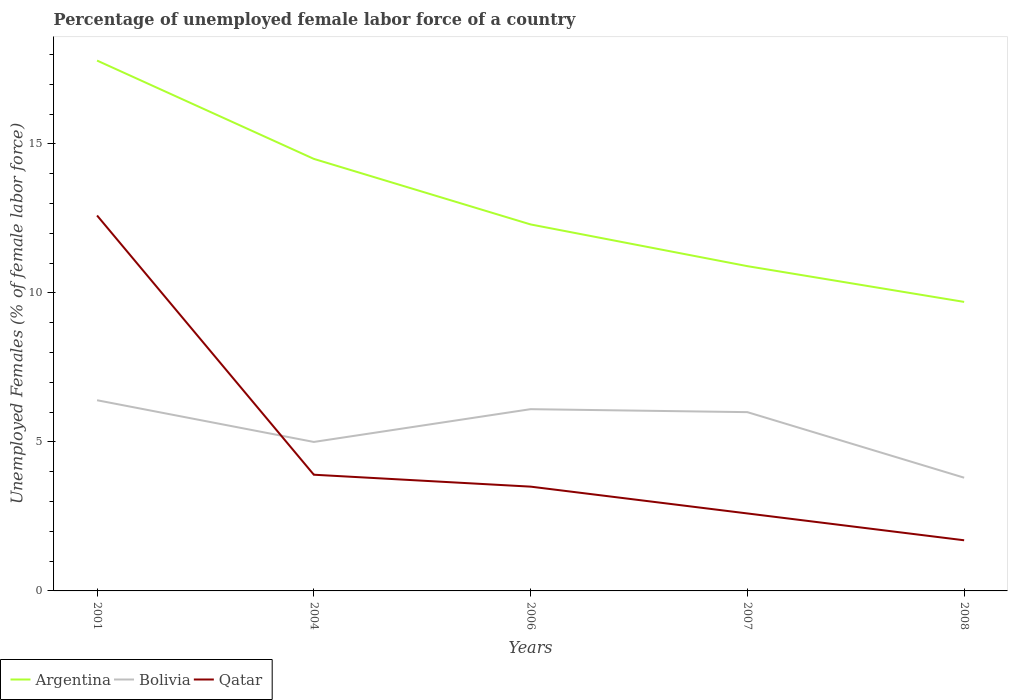How many different coloured lines are there?
Offer a very short reply. 3. Does the line corresponding to Qatar intersect with the line corresponding to Argentina?
Keep it short and to the point. No. Is the number of lines equal to the number of legend labels?
Offer a very short reply. Yes. Across all years, what is the maximum percentage of unemployed female labor force in Bolivia?
Provide a short and direct response. 3.8. In which year was the percentage of unemployed female labor force in Bolivia maximum?
Your response must be concise. 2008. What is the total percentage of unemployed female labor force in Argentina in the graph?
Make the answer very short. 2.2. What is the difference between the highest and the second highest percentage of unemployed female labor force in Qatar?
Keep it short and to the point. 10.9. What is the difference between the highest and the lowest percentage of unemployed female labor force in Argentina?
Ensure brevity in your answer.  2. Is the percentage of unemployed female labor force in Argentina strictly greater than the percentage of unemployed female labor force in Bolivia over the years?
Your answer should be compact. No. How many lines are there?
Offer a very short reply. 3. How many years are there in the graph?
Give a very brief answer. 5. Are the values on the major ticks of Y-axis written in scientific E-notation?
Offer a very short reply. No. Does the graph contain any zero values?
Offer a very short reply. No. How are the legend labels stacked?
Provide a succinct answer. Horizontal. What is the title of the graph?
Your answer should be compact. Percentage of unemployed female labor force of a country. Does "Syrian Arab Republic" appear as one of the legend labels in the graph?
Provide a succinct answer. No. What is the label or title of the Y-axis?
Keep it short and to the point. Unemployed Females (% of female labor force). What is the Unemployed Females (% of female labor force) of Argentina in 2001?
Make the answer very short. 17.8. What is the Unemployed Females (% of female labor force) in Bolivia in 2001?
Give a very brief answer. 6.4. What is the Unemployed Females (% of female labor force) of Qatar in 2001?
Make the answer very short. 12.6. What is the Unemployed Females (% of female labor force) in Bolivia in 2004?
Your response must be concise. 5. What is the Unemployed Females (% of female labor force) in Qatar in 2004?
Your response must be concise. 3.9. What is the Unemployed Females (% of female labor force) in Argentina in 2006?
Your answer should be very brief. 12.3. What is the Unemployed Females (% of female labor force) in Bolivia in 2006?
Your answer should be compact. 6.1. What is the Unemployed Females (% of female labor force) of Qatar in 2006?
Offer a terse response. 3.5. What is the Unemployed Females (% of female labor force) of Argentina in 2007?
Your response must be concise. 10.9. What is the Unemployed Females (% of female labor force) of Qatar in 2007?
Offer a very short reply. 2.6. What is the Unemployed Females (% of female labor force) of Argentina in 2008?
Make the answer very short. 9.7. What is the Unemployed Females (% of female labor force) in Bolivia in 2008?
Your answer should be compact. 3.8. What is the Unemployed Females (% of female labor force) of Qatar in 2008?
Your answer should be very brief. 1.7. Across all years, what is the maximum Unemployed Females (% of female labor force) in Argentina?
Provide a short and direct response. 17.8. Across all years, what is the maximum Unemployed Females (% of female labor force) of Bolivia?
Provide a succinct answer. 6.4. Across all years, what is the maximum Unemployed Females (% of female labor force) of Qatar?
Your answer should be very brief. 12.6. Across all years, what is the minimum Unemployed Females (% of female labor force) in Argentina?
Your answer should be very brief. 9.7. Across all years, what is the minimum Unemployed Females (% of female labor force) of Bolivia?
Ensure brevity in your answer.  3.8. Across all years, what is the minimum Unemployed Females (% of female labor force) of Qatar?
Give a very brief answer. 1.7. What is the total Unemployed Females (% of female labor force) in Argentina in the graph?
Provide a succinct answer. 65.2. What is the total Unemployed Females (% of female labor force) in Bolivia in the graph?
Your response must be concise. 27.3. What is the total Unemployed Females (% of female labor force) in Qatar in the graph?
Give a very brief answer. 24.3. What is the difference between the Unemployed Females (% of female labor force) in Argentina in 2001 and that in 2004?
Offer a very short reply. 3.3. What is the difference between the Unemployed Females (% of female labor force) of Bolivia in 2001 and that in 2004?
Offer a very short reply. 1.4. What is the difference between the Unemployed Females (% of female labor force) of Qatar in 2001 and that in 2004?
Your answer should be very brief. 8.7. What is the difference between the Unemployed Females (% of female labor force) of Argentina in 2001 and that in 2006?
Keep it short and to the point. 5.5. What is the difference between the Unemployed Females (% of female labor force) in Bolivia in 2001 and that in 2006?
Provide a short and direct response. 0.3. What is the difference between the Unemployed Females (% of female labor force) of Qatar in 2001 and that in 2006?
Give a very brief answer. 9.1. What is the difference between the Unemployed Females (% of female labor force) in Bolivia in 2001 and that in 2007?
Offer a terse response. 0.4. What is the difference between the Unemployed Females (% of female labor force) in Qatar in 2001 and that in 2007?
Your answer should be compact. 10. What is the difference between the Unemployed Females (% of female labor force) in Bolivia in 2004 and that in 2006?
Make the answer very short. -1.1. What is the difference between the Unemployed Females (% of female labor force) in Qatar in 2004 and that in 2006?
Provide a succinct answer. 0.4. What is the difference between the Unemployed Females (% of female labor force) of Argentina in 2004 and that in 2007?
Ensure brevity in your answer.  3.6. What is the difference between the Unemployed Females (% of female labor force) in Qatar in 2004 and that in 2007?
Provide a short and direct response. 1.3. What is the difference between the Unemployed Females (% of female labor force) of Argentina in 2004 and that in 2008?
Provide a short and direct response. 4.8. What is the difference between the Unemployed Females (% of female labor force) of Bolivia in 2006 and that in 2007?
Your answer should be very brief. 0.1. What is the difference between the Unemployed Females (% of female labor force) of Qatar in 2006 and that in 2007?
Provide a short and direct response. 0.9. What is the difference between the Unemployed Females (% of female labor force) in Argentina in 2006 and that in 2008?
Provide a short and direct response. 2.6. What is the difference between the Unemployed Females (% of female labor force) in Qatar in 2006 and that in 2008?
Your answer should be very brief. 1.8. What is the difference between the Unemployed Females (% of female labor force) of Qatar in 2007 and that in 2008?
Offer a very short reply. 0.9. What is the difference between the Unemployed Females (% of female labor force) in Argentina in 2001 and the Unemployed Females (% of female labor force) in Bolivia in 2004?
Your answer should be very brief. 12.8. What is the difference between the Unemployed Females (% of female labor force) of Argentina in 2001 and the Unemployed Females (% of female labor force) of Qatar in 2006?
Your response must be concise. 14.3. What is the difference between the Unemployed Females (% of female labor force) of Bolivia in 2001 and the Unemployed Females (% of female labor force) of Qatar in 2006?
Ensure brevity in your answer.  2.9. What is the difference between the Unemployed Females (% of female labor force) in Argentina in 2001 and the Unemployed Females (% of female labor force) in Bolivia in 2007?
Make the answer very short. 11.8. What is the difference between the Unemployed Females (% of female labor force) in Argentina in 2001 and the Unemployed Females (% of female labor force) in Qatar in 2007?
Make the answer very short. 15.2. What is the difference between the Unemployed Females (% of female labor force) of Bolivia in 2001 and the Unemployed Females (% of female labor force) of Qatar in 2007?
Ensure brevity in your answer.  3.8. What is the difference between the Unemployed Females (% of female labor force) of Argentina in 2001 and the Unemployed Females (% of female labor force) of Qatar in 2008?
Offer a very short reply. 16.1. What is the difference between the Unemployed Females (% of female labor force) in Bolivia in 2001 and the Unemployed Females (% of female labor force) in Qatar in 2008?
Give a very brief answer. 4.7. What is the difference between the Unemployed Females (% of female labor force) in Argentina in 2004 and the Unemployed Females (% of female labor force) in Qatar in 2006?
Your answer should be very brief. 11. What is the difference between the Unemployed Females (% of female labor force) of Bolivia in 2004 and the Unemployed Females (% of female labor force) of Qatar in 2006?
Keep it short and to the point. 1.5. What is the difference between the Unemployed Females (% of female labor force) of Argentina in 2004 and the Unemployed Females (% of female labor force) of Bolivia in 2008?
Ensure brevity in your answer.  10.7. What is the difference between the Unemployed Females (% of female labor force) of Argentina in 2006 and the Unemployed Females (% of female labor force) of Qatar in 2007?
Your answer should be compact. 9.7. What is the difference between the Unemployed Females (% of female labor force) in Bolivia in 2006 and the Unemployed Females (% of female labor force) in Qatar in 2007?
Ensure brevity in your answer.  3.5. What is the difference between the Unemployed Females (% of female labor force) in Bolivia in 2006 and the Unemployed Females (% of female labor force) in Qatar in 2008?
Ensure brevity in your answer.  4.4. What is the difference between the Unemployed Females (% of female labor force) in Argentina in 2007 and the Unemployed Females (% of female labor force) in Qatar in 2008?
Provide a short and direct response. 9.2. What is the average Unemployed Females (% of female labor force) of Argentina per year?
Ensure brevity in your answer.  13.04. What is the average Unemployed Females (% of female labor force) of Bolivia per year?
Provide a short and direct response. 5.46. What is the average Unemployed Females (% of female labor force) in Qatar per year?
Give a very brief answer. 4.86. In the year 2001, what is the difference between the Unemployed Females (% of female labor force) of Bolivia and Unemployed Females (% of female labor force) of Qatar?
Make the answer very short. -6.2. In the year 2004, what is the difference between the Unemployed Females (% of female labor force) of Argentina and Unemployed Females (% of female labor force) of Bolivia?
Your answer should be very brief. 9.5. In the year 2004, what is the difference between the Unemployed Females (% of female labor force) in Argentina and Unemployed Females (% of female labor force) in Qatar?
Ensure brevity in your answer.  10.6. In the year 2006, what is the difference between the Unemployed Females (% of female labor force) of Argentina and Unemployed Females (% of female labor force) of Bolivia?
Offer a terse response. 6.2. In the year 2006, what is the difference between the Unemployed Females (% of female labor force) of Argentina and Unemployed Females (% of female labor force) of Qatar?
Your response must be concise. 8.8. In the year 2006, what is the difference between the Unemployed Females (% of female labor force) of Bolivia and Unemployed Females (% of female labor force) of Qatar?
Offer a terse response. 2.6. In the year 2008, what is the difference between the Unemployed Females (% of female labor force) of Argentina and Unemployed Females (% of female labor force) of Bolivia?
Make the answer very short. 5.9. In the year 2008, what is the difference between the Unemployed Females (% of female labor force) in Bolivia and Unemployed Females (% of female labor force) in Qatar?
Your answer should be very brief. 2.1. What is the ratio of the Unemployed Females (% of female labor force) in Argentina in 2001 to that in 2004?
Keep it short and to the point. 1.23. What is the ratio of the Unemployed Females (% of female labor force) in Bolivia in 2001 to that in 2004?
Offer a very short reply. 1.28. What is the ratio of the Unemployed Females (% of female labor force) of Qatar in 2001 to that in 2004?
Provide a short and direct response. 3.23. What is the ratio of the Unemployed Females (% of female labor force) in Argentina in 2001 to that in 2006?
Provide a succinct answer. 1.45. What is the ratio of the Unemployed Females (% of female labor force) of Bolivia in 2001 to that in 2006?
Offer a terse response. 1.05. What is the ratio of the Unemployed Females (% of female labor force) of Qatar in 2001 to that in 2006?
Keep it short and to the point. 3.6. What is the ratio of the Unemployed Females (% of female labor force) in Argentina in 2001 to that in 2007?
Ensure brevity in your answer.  1.63. What is the ratio of the Unemployed Females (% of female labor force) of Bolivia in 2001 to that in 2007?
Your answer should be very brief. 1.07. What is the ratio of the Unemployed Females (% of female labor force) of Qatar in 2001 to that in 2007?
Ensure brevity in your answer.  4.85. What is the ratio of the Unemployed Females (% of female labor force) in Argentina in 2001 to that in 2008?
Make the answer very short. 1.84. What is the ratio of the Unemployed Females (% of female labor force) of Bolivia in 2001 to that in 2008?
Your answer should be very brief. 1.68. What is the ratio of the Unemployed Females (% of female labor force) in Qatar in 2001 to that in 2008?
Your answer should be very brief. 7.41. What is the ratio of the Unemployed Females (% of female labor force) of Argentina in 2004 to that in 2006?
Ensure brevity in your answer.  1.18. What is the ratio of the Unemployed Females (% of female labor force) of Bolivia in 2004 to that in 2006?
Make the answer very short. 0.82. What is the ratio of the Unemployed Females (% of female labor force) in Qatar in 2004 to that in 2006?
Make the answer very short. 1.11. What is the ratio of the Unemployed Females (% of female labor force) in Argentina in 2004 to that in 2007?
Provide a succinct answer. 1.33. What is the ratio of the Unemployed Females (% of female labor force) in Argentina in 2004 to that in 2008?
Provide a short and direct response. 1.49. What is the ratio of the Unemployed Females (% of female labor force) of Bolivia in 2004 to that in 2008?
Offer a very short reply. 1.32. What is the ratio of the Unemployed Females (% of female labor force) of Qatar in 2004 to that in 2008?
Your answer should be very brief. 2.29. What is the ratio of the Unemployed Females (% of female labor force) of Argentina in 2006 to that in 2007?
Offer a terse response. 1.13. What is the ratio of the Unemployed Females (% of female labor force) in Bolivia in 2006 to that in 2007?
Provide a succinct answer. 1.02. What is the ratio of the Unemployed Females (% of female labor force) in Qatar in 2006 to that in 2007?
Provide a short and direct response. 1.35. What is the ratio of the Unemployed Females (% of female labor force) of Argentina in 2006 to that in 2008?
Offer a terse response. 1.27. What is the ratio of the Unemployed Females (% of female labor force) of Bolivia in 2006 to that in 2008?
Your response must be concise. 1.61. What is the ratio of the Unemployed Females (% of female labor force) of Qatar in 2006 to that in 2008?
Make the answer very short. 2.06. What is the ratio of the Unemployed Females (% of female labor force) of Argentina in 2007 to that in 2008?
Keep it short and to the point. 1.12. What is the ratio of the Unemployed Females (% of female labor force) in Bolivia in 2007 to that in 2008?
Provide a succinct answer. 1.58. What is the ratio of the Unemployed Females (% of female labor force) of Qatar in 2007 to that in 2008?
Your answer should be very brief. 1.53. What is the difference between the highest and the second highest Unemployed Females (% of female labor force) of Argentina?
Your answer should be compact. 3.3. What is the difference between the highest and the second highest Unemployed Females (% of female labor force) in Bolivia?
Your answer should be very brief. 0.3. What is the difference between the highest and the lowest Unemployed Females (% of female labor force) in Argentina?
Your answer should be compact. 8.1. What is the difference between the highest and the lowest Unemployed Females (% of female labor force) of Bolivia?
Make the answer very short. 2.6. 